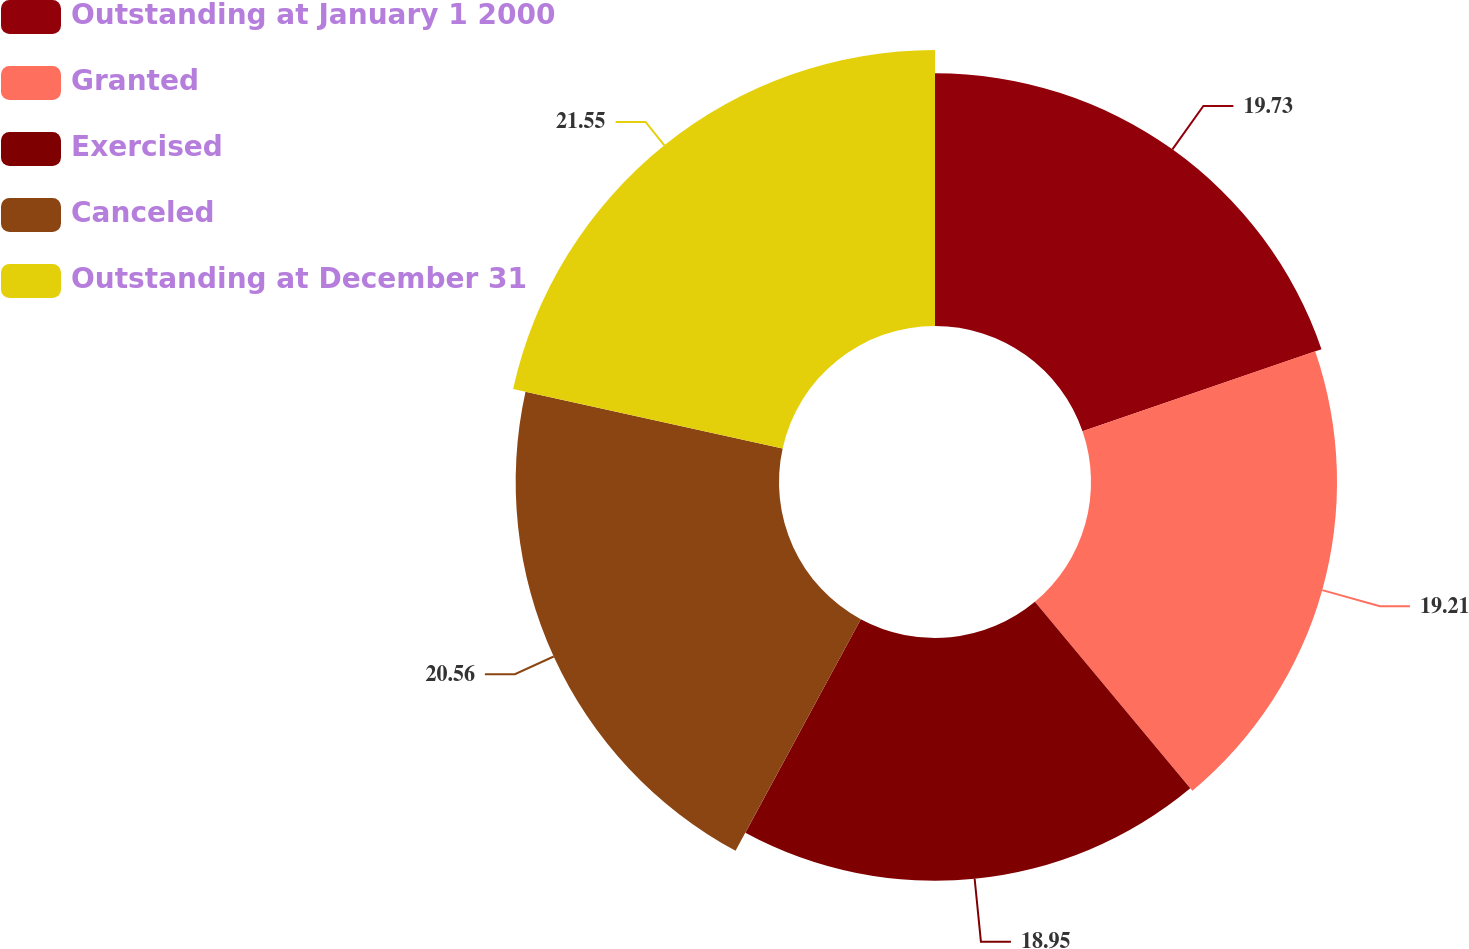Convert chart. <chart><loc_0><loc_0><loc_500><loc_500><pie_chart><fcel>Outstanding at January 1 2000<fcel>Granted<fcel>Exercised<fcel>Canceled<fcel>Outstanding at December 31<nl><fcel>19.73%<fcel>19.21%<fcel>18.95%<fcel>20.56%<fcel>21.55%<nl></chart> 